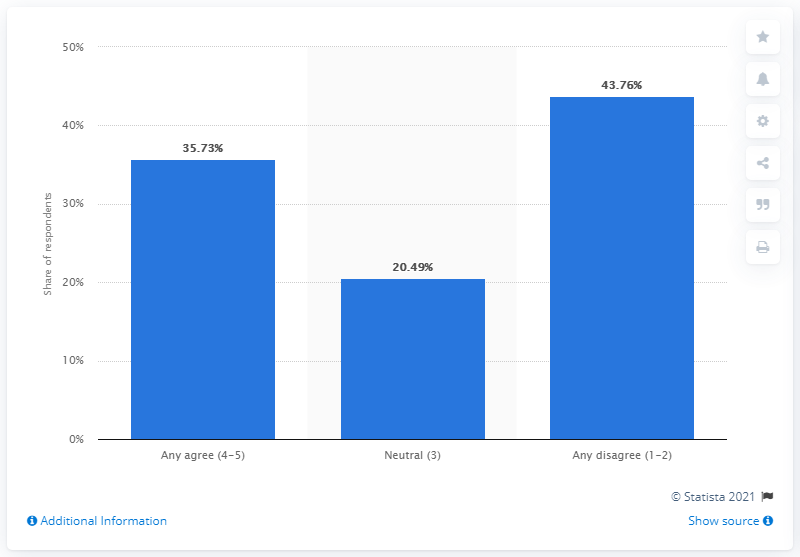Specify some key components in this picture. According to a survey, 35.73% of Canadians reported feeling the need to check social networking sites every day. 